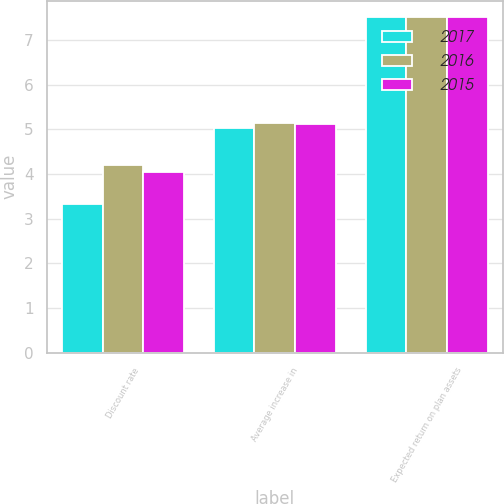<chart> <loc_0><loc_0><loc_500><loc_500><stacked_bar_chart><ecel><fcel>Discount rate<fcel>Average increase in<fcel>Expected return on plan assets<nl><fcel>2017<fcel>3.33<fcel>5.02<fcel>7.5<nl><fcel>2016<fcel>4.19<fcel>5.14<fcel>7.5<nl><fcel>2015<fcel>4.05<fcel>5.12<fcel>7.5<nl></chart> 